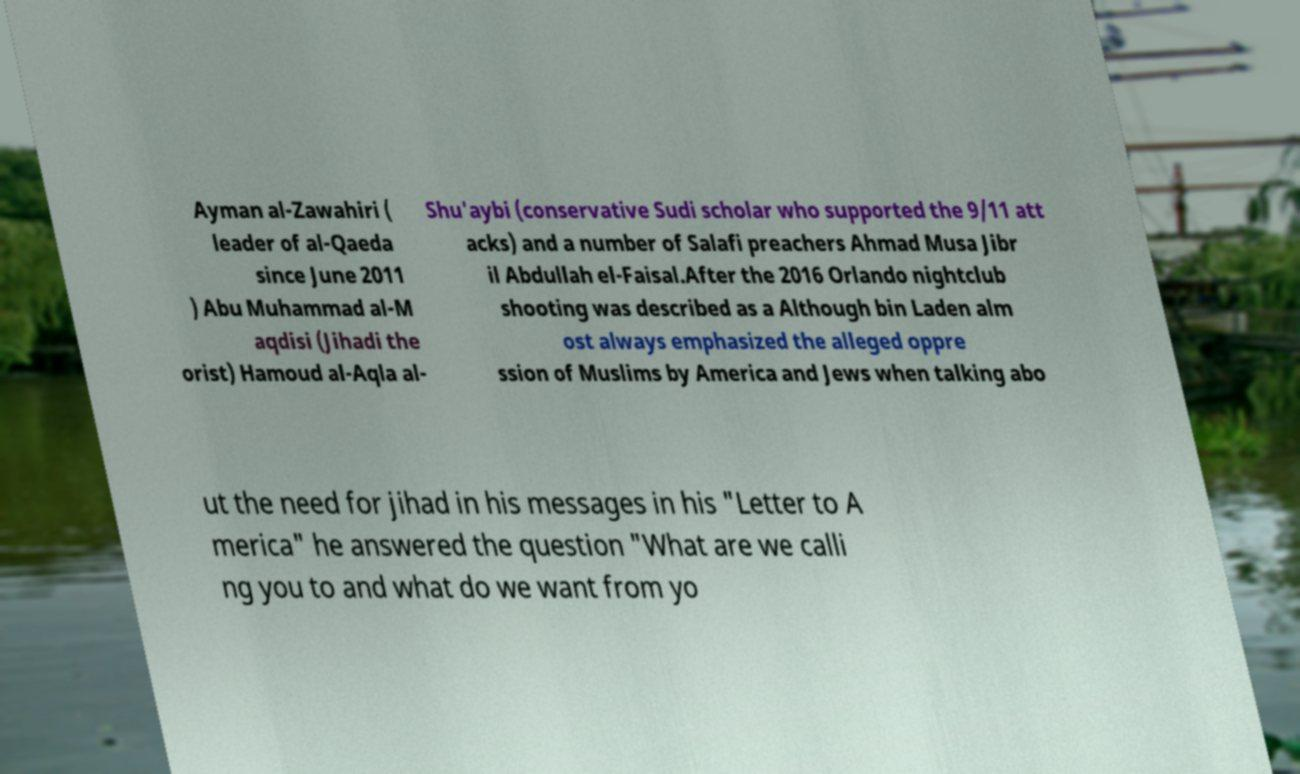There's text embedded in this image that I need extracted. Can you transcribe it verbatim? Ayman al-Zawahiri ( leader of al-Qaeda since June 2011 ) Abu Muhammad al-M aqdisi (Jihadi the orist) Hamoud al-Aqla al- Shu'aybi (conservative Sudi scholar who supported the 9/11 att acks) and a number of Salafi preachers Ahmad Musa Jibr il Abdullah el-Faisal.After the 2016 Orlando nightclub shooting was described as a Although bin Laden alm ost always emphasized the alleged oppre ssion of Muslims by America and Jews when talking abo ut the need for jihad in his messages in his "Letter to A merica" he answered the question "What are we calli ng you to and what do we want from yo 